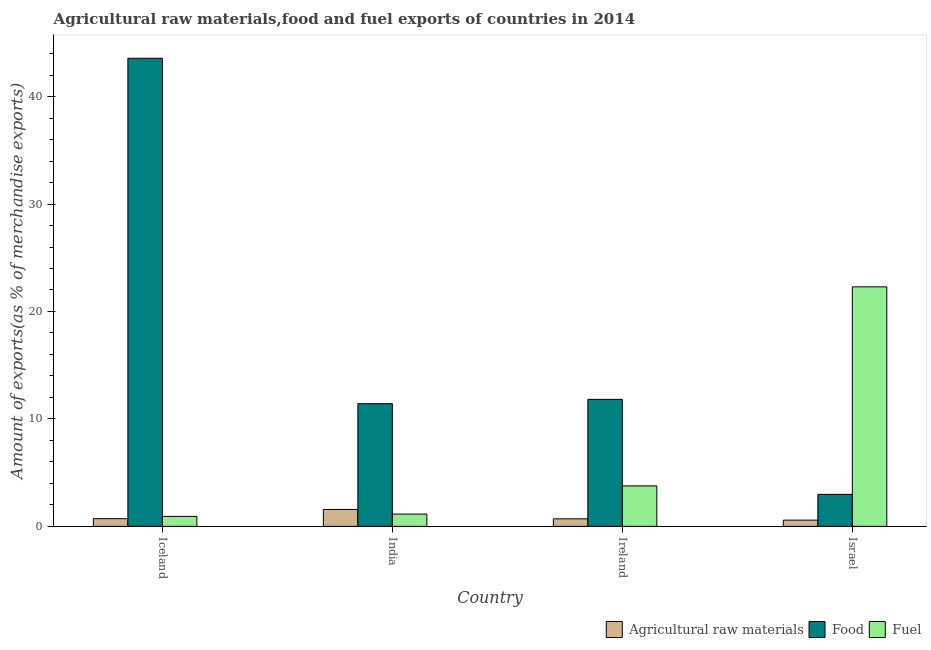How many different coloured bars are there?
Offer a terse response. 3. How many groups of bars are there?
Your answer should be very brief. 4. Are the number of bars on each tick of the X-axis equal?
Offer a terse response. Yes. How many bars are there on the 3rd tick from the left?
Ensure brevity in your answer.  3. How many bars are there on the 3rd tick from the right?
Make the answer very short. 3. What is the label of the 2nd group of bars from the left?
Your answer should be very brief. India. What is the percentage of raw materials exports in India?
Your response must be concise. 1.57. Across all countries, what is the maximum percentage of food exports?
Keep it short and to the point. 43.56. Across all countries, what is the minimum percentage of raw materials exports?
Give a very brief answer. 0.58. In which country was the percentage of fuel exports minimum?
Provide a succinct answer. Iceland. What is the total percentage of raw materials exports in the graph?
Make the answer very short. 3.57. What is the difference between the percentage of fuel exports in India and that in Israel?
Keep it short and to the point. -21.15. What is the difference between the percentage of food exports in Israel and the percentage of raw materials exports in Ireland?
Give a very brief answer. 2.27. What is the average percentage of raw materials exports per country?
Provide a succinct answer. 0.89. What is the difference between the percentage of food exports and percentage of fuel exports in Ireland?
Your answer should be compact. 8.05. What is the ratio of the percentage of raw materials exports in Iceland to that in India?
Your response must be concise. 0.46. Is the percentage of food exports in Ireland less than that in Israel?
Offer a very short reply. No. Is the difference between the percentage of food exports in Iceland and Ireland greater than the difference between the percentage of fuel exports in Iceland and Ireland?
Make the answer very short. Yes. What is the difference between the highest and the second highest percentage of fuel exports?
Provide a short and direct response. 18.52. What is the difference between the highest and the lowest percentage of food exports?
Give a very brief answer. 40.59. In how many countries, is the percentage of fuel exports greater than the average percentage of fuel exports taken over all countries?
Provide a short and direct response. 1. What does the 1st bar from the left in Iceland represents?
Make the answer very short. Agricultural raw materials. What does the 3rd bar from the right in Ireland represents?
Ensure brevity in your answer.  Agricultural raw materials. How many bars are there?
Provide a short and direct response. 12. What is the difference between two consecutive major ticks on the Y-axis?
Your answer should be compact. 10. Are the values on the major ticks of Y-axis written in scientific E-notation?
Provide a short and direct response. No. Does the graph contain any zero values?
Keep it short and to the point. No. Does the graph contain grids?
Your response must be concise. No. How many legend labels are there?
Ensure brevity in your answer.  3. What is the title of the graph?
Your answer should be very brief. Agricultural raw materials,food and fuel exports of countries in 2014. What is the label or title of the X-axis?
Give a very brief answer. Country. What is the label or title of the Y-axis?
Give a very brief answer. Amount of exports(as % of merchandise exports). What is the Amount of exports(as % of merchandise exports) of Agricultural raw materials in Iceland?
Ensure brevity in your answer.  0.72. What is the Amount of exports(as % of merchandise exports) of Food in Iceland?
Make the answer very short. 43.56. What is the Amount of exports(as % of merchandise exports) of Fuel in Iceland?
Keep it short and to the point. 0.93. What is the Amount of exports(as % of merchandise exports) in Agricultural raw materials in India?
Ensure brevity in your answer.  1.57. What is the Amount of exports(as % of merchandise exports) of Food in India?
Give a very brief answer. 11.42. What is the Amount of exports(as % of merchandise exports) in Fuel in India?
Your response must be concise. 1.14. What is the Amount of exports(as % of merchandise exports) in Agricultural raw materials in Ireland?
Provide a succinct answer. 0.7. What is the Amount of exports(as % of merchandise exports) in Food in Ireland?
Give a very brief answer. 11.82. What is the Amount of exports(as % of merchandise exports) of Fuel in Ireland?
Provide a succinct answer. 3.77. What is the Amount of exports(as % of merchandise exports) in Agricultural raw materials in Israel?
Ensure brevity in your answer.  0.58. What is the Amount of exports(as % of merchandise exports) of Food in Israel?
Your answer should be compact. 2.98. What is the Amount of exports(as % of merchandise exports) of Fuel in Israel?
Provide a short and direct response. 22.29. Across all countries, what is the maximum Amount of exports(as % of merchandise exports) in Agricultural raw materials?
Provide a short and direct response. 1.57. Across all countries, what is the maximum Amount of exports(as % of merchandise exports) of Food?
Offer a terse response. 43.56. Across all countries, what is the maximum Amount of exports(as % of merchandise exports) of Fuel?
Keep it short and to the point. 22.29. Across all countries, what is the minimum Amount of exports(as % of merchandise exports) in Agricultural raw materials?
Your response must be concise. 0.58. Across all countries, what is the minimum Amount of exports(as % of merchandise exports) of Food?
Make the answer very short. 2.98. Across all countries, what is the minimum Amount of exports(as % of merchandise exports) of Fuel?
Keep it short and to the point. 0.93. What is the total Amount of exports(as % of merchandise exports) in Agricultural raw materials in the graph?
Your answer should be very brief. 3.57. What is the total Amount of exports(as % of merchandise exports) in Food in the graph?
Your response must be concise. 69.78. What is the total Amount of exports(as % of merchandise exports) of Fuel in the graph?
Ensure brevity in your answer.  28.13. What is the difference between the Amount of exports(as % of merchandise exports) of Agricultural raw materials in Iceland and that in India?
Offer a very short reply. -0.86. What is the difference between the Amount of exports(as % of merchandise exports) of Food in Iceland and that in India?
Your answer should be very brief. 32.15. What is the difference between the Amount of exports(as % of merchandise exports) of Fuel in Iceland and that in India?
Your answer should be very brief. -0.22. What is the difference between the Amount of exports(as % of merchandise exports) of Agricultural raw materials in Iceland and that in Ireland?
Keep it short and to the point. 0.01. What is the difference between the Amount of exports(as % of merchandise exports) of Food in Iceland and that in Ireland?
Your answer should be compact. 31.74. What is the difference between the Amount of exports(as % of merchandise exports) of Fuel in Iceland and that in Ireland?
Ensure brevity in your answer.  -2.84. What is the difference between the Amount of exports(as % of merchandise exports) of Agricultural raw materials in Iceland and that in Israel?
Provide a succinct answer. 0.14. What is the difference between the Amount of exports(as % of merchandise exports) of Food in Iceland and that in Israel?
Give a very brief answer. 40.59. What is the difference between the Amount of exports(as % of merchandise exports) in Fuel in Iceland and that in Israel?
Keep it short and to the point. -21.36. What is the difference between the Amount of exports(as % of merchandise exports) of Agricultural raw materials in India and that in Ireland?
Provide a short and direct response. 0.87. What is the difference between the Amount of exports(as % of merchandise exports) in Food in India and that in Ireland?
Make the answer very short. -0.4. What is the difference between the Amount of exports(as % of merchandise exports) in Fuel in India and that in Ireland?
Ensure brevity in your answer.  -2.62. What is the difference between the Amount of exports(as % of merchandise exports) of Food in India and that in Israel?
Your answer should be compact. 8.44. What is the difference between the Amount of exports(as % of merchandise exports) in Fuel in India and that in Israel?
Give a very brief answer. -21.15. What is the difference between the Amount of exports(as % of merchandise exports) in Agricultural raw materials in Ireland and that in Israel?
Ensure brevity in your answer.  0.12. What is the difference between the Amount of exports(as % of merchandise exports) in Food in Ireland and that in Israel?
Your answer should be very brief. 8.84. What is the difference between the Amount of exports(as % of merchandise exports) of Fuel in Ireland and that in Israel?
Your answer should be very brief. -18.52. What is the difference between the Amount of exports(as % of merchandise exports) of Agricultural raw materials in Iceland and the Amount of exports(as % of merchandise exports) of Food in India?
Make the answer very short. -10.7. What is the difference between the Amount of exports(as % of merchandise exports) of Agricultural raw materials in Iceland and the Amount of exports(as % of merchandise exports) of Fuel in India?
Give a very brief answer. -0.43. What is the difference between the Amount of exports(as % of merchandise exports) of Food in Iceland and the Amount of exports(as % of merchandise exports) of Fuel in India?
Provide a succinct answer. 42.42. What is the difference between the Amount of exports(as % of merchandise exports) of Agricultural raw materials in Iceland and the Amount of exports(as % of merchandise exports) of Food in Ireland?
Make the answer very short. -11.1. What is the difference between the Amount of exports(as % of merchandise exports) in Agricultural raw materials in Iceland and the Amount of exports(as % of merchandise exports) in Fuel in Ireland?
Provide a succinct answer. -3.05. What is the difference between the Amount of exports(as % of merchandise exports) in Food in Iceland and the Amount of exports(as % of merchandise exports) in Fuel in Ireland?
Your response must be concise. 39.8. What is the difference between the Amount of exports(as % of merchandise exports) in Agricultural raw materials in Iceland and the Amount of exports(as % of merchandise exports) in Food in Israel?
Offer a very short reply. -2.26. What is the difference between the Amount of exports(as % of merchandise exports) of Agricultural raw materials in Iceland and the Amount of exports(as % of merchandise exports) of Fuel in Israel?
Your answer should be compact. -21.58. What is the difference between the Amount of exports(as % of merchandise exports) of Food in Iceland and the Amount of exports(as % of merchandise exports) of Fuel in Israel?
Your response must be concise. 21.27. What is the difference between the Amount of exports(as % of merchandise exports) of Agricultural raw materials in India and the Amount of exports(as % of merchandise exports) of Food in Ireland?
Your response must be concise. -10.25. What is the difference between the Amount of exports(as % of merchandise exports) in Agricultural raw materials in India and the Amount of exports(as % of merchandise exports) in Fuel in Ireland?
Your response must be concise. -2.19. What is the difference between the Amount of exports(as % of merchandise exports) in Food in India and the Amount of exports(as % of merchandise exports) in Fuel in Ireland?
Make the answer very short. 7.65. What is the difference between the Amount of exports(as % of merchandise exports) in Agricultural raw materials in India and the Amount of exports(as % of merchandise exports) in Food in Israel?
Keep it short and to the point. -1.4. What is the difference between the Amount of exports(as % of merchandise exports) of Agricultural raw materials in India and the Amount of exports(as % of merchandise exports) of Fuel in Israel?
Make the answer very short. -20.72. What is the difference between the Amount of exports(as % of merchandise exports) in Food in India and the Amount of exports(as % of merchandise exports) in Fuel in Israel?
Keep it short and to the point. -10.87. What is the difference between the Amount of exports(as % of merchandise exports) of Agricultural raw materials in Ireland and the Amount of exports(as % of merchandise exports) of Food in Israel?
Give a very brief answer. -2.27. What is the difference between the Amount of exports(as % of merchandise exports) in Agricultural raw materials in Ireland and the Amount of exports(as % of merchandise exports) in Fuel in Israel?
Your answer should be compact. -21.59. What is the difference between the Amount of exports(as % of merchandise exports) in Food in Ireland and the Amount of exports(as % of merchandise exports) in Fuel in Israel?
Make the answer very short. -10.47. What is the average Amount of exports(as % of merchandise exports) of Agricultural raw materials per country?
Give a very brief answer. 0.89. What is the average Amount of exports(as % of merchandise exports) in Food per country?
Give a very brief answer. 17.45. What is the average Amount of exports(as % of merchandise exports) in Fuel per country?
Ensure brevity in your answer.  7.03. What is the difference between the Amount of exports(as % of merchandise exports) of Agricultural raw materials and Amount of exports(as % of merchandise exports) of Food in Iceland?
Give a very brief answer. -42.85. What is the difference between the Amount of exports(as % of merchandise exports) of Agricultural raw materials and Amount of exports(as % of merchandise exports) of Fuel in Iceland?
Offer a terse response. -0.21. What is the difference between the Amount of exports(as % of merchandise exports) of Food and Amount of exports(as % of merchandise exports) of Fuel in Iceland?
Offer a very short reply. 42.63. What is the difference between the Amount of exports(as % of merchandise exports) in Agricultural raw materials and Amount of exports(as % of merchandise exports) in Food in India?
Keep it short and to the point. -9.84. What is the difference between the Amount of exports(as % of merchandise exports) in Agricultural raw materials and Amount of exports(as % of merchandise exports) in Fuel in India?
Offer a terse response. 0.43. What is the difference between the Amount of exports(as % of merchandise exports) of Food and Amount of exports(as % of merchandise exports) of Fuel in India?
Ensure brevity in your answer.  10.27. What is the difference between the Amount of exports(as % of merchandise exports) of Agricultural raw materials and Amount of exports(as % of merchandise exports) of Food in Ireland?
Offer a very short reply. -11.12. What is the difference between the Amount of exports(as % of merchandise exports) in Agricultural raw materials and Amount of exports(as % of merchandise exports) in Fuel in Ireland?
Provide a short and direct response. -3.07. What is the difference between the Amount of exports(as % of merchandise exports) in Food and Amount of exports(as % of merchandise exports) in Fuel in Ireland?
Provide a succinct answer. 8.05. What is the difference between the Amount of exports(as % of merchandise exports) in Agricultural raw materials and Amount of exports(as % of merchandise exports) in Food in Israel?
Give a very brief answer. -2.4. What is the difference between the Amount of exports(as % of merchandise exports) of Agricultural raw materials and Amount of exports(as % of merchandise exports) of Fuel in Israel?
Give a very brief answer. -21.71. What is the difference between the Amount of exports(as % of merchandise exports) in Food and Amount of exports(as % of merchandise exports) in Fuel in Israel?
Give a very brief answer. -19.32. What is the ratio of the Amount of exports(as % of merchandise exports) in Agricultural raw materials in Iceland to that in India?
Keep it short and to the point. 0.46. What is the ratio of the Amount of exports(as % of merchandise exports) in Food in Iceland to that in India?
Provide a short and direct response. 3.82. What is the ratio of the Amount of exports(as % of merchandise exports) in Fuel in Iceland to that in India?
Offer a terse response. 0.81. What is the ratio of the Amount of exports(as % of merchandise exports) of Agricultural raw materials in Iceland to that in Ireland?
Give a very brief answer. 1.02. What is the ratio of the Amount of exports(as % of merchandise exports) of Food in Iceland to that in Ireland?
Give a very brief answer. 3.69. What is the ratio of the Amount of exports(as % of merchandise exports) in Fuel in Iceland to that in Ireland?
Ensure brevity in your answer.  0.25. What is the ratio of the Amount of exports(as % of merchandise exports) of Agricultural raw materials in Iceland to that in Israel?
Ensure brevity in your answer.  1.23. What is the ratio of the Amount of exports(as % of merchandise exports) in Food in Iceland to that in Israel?
Offer a terse response. 14.64. What is the ratio of the Amount of exports(as % of merchandise exports) of Fuel in Iceland to that in Israel?
Offer a terse response. 0.04. What is the ratio of the Amount of exports(as % of merchandise exports) of Agricultural raw materials in India to that in Ireland?
Keep it short and to the point. 2.24. What is the ratio of the Amount of exports(as % of merchandise exports) of Food in India to that in Ireland?
Give a very brief answer. 0.97. What is the ratio of the Amount of exports(as % of merchandise exports) in Fuel in India to that in Ireland?
Your answer should be very brief. 0.3. What is the ratio of the Amount of exports(as % of merchandise exports) in Agricultural raw materials in India to that in Israel?
Provide a short and direct response. 2.71. What is the ratio of the Amount of exports(as % of merchandise exports) in Food in India to that in Israel?
Provide a short and direct response. 3.84. What is the ratio of the Amount of exports(as % of merchandise exports) of Fuel in India to that in Israel?
Give a very brief answer. 0.05. What is the ratio of the Amount of exports(as % of merchandise exports) of Agricultural raw materials in Ireland to that in Israel?
Provide a succinct answer. 1.21. What is the ratio of the Amount of exports(as % of merchandise exports) of Food in Ireland to that in Israel?
Keep it short and to the point. 3.97. What is the ratio of the Amount of exports(as % of merchandise exports) of Fuel in Ireland to that in Israel?
Your answer should be compact. 0.17. What is the difference between the highest and the second highest Amount of exports(as % of merchandise exports) of Agricultural raw materials?
Offer a terse response. 0.86. What is the difference between the highest and the second highest Amount of exports(as % of merchandise exports) of Food?
Give a very brief answer. 31.74. What is the difference between the highest and the second highest Amount of exports(as % of merchandise exports) of Fuel?
Offer a terse response. 18.52. What is the difference between the highest and the lowest Amount of exports(as % of merchandise exports) in Food?
Provide a short and direct response. 40.59. What is the difference between the highest and the lowest Amount of exports(as % of merchandise exports) of Fuel?
Provide a short and direct response. 21.36. 